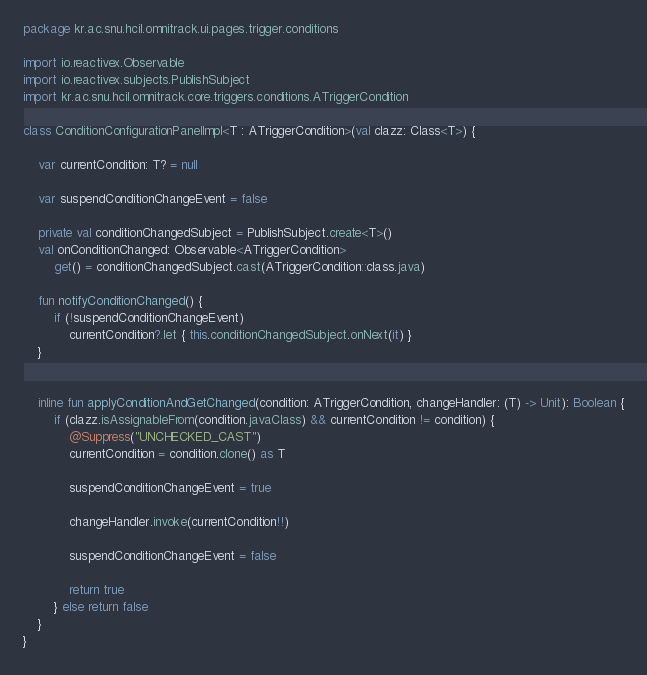<code> <loc_0><loc_0><loc_500><loc_500><_Kotlin_>package kr.ac.snu.hcil.omnitrack.ui.pages.trigger.conditions

import io.reactivex.Observable
import io.reactivex.subjects.PublishSubject
import kr.ac.snu.hcil.omnitrack.core.triggers.conditions.ATriggerCondition

class ConditionConfigurationPanelImpl<T : ATriggerCondition>(val clazz: Class<T>) {

    var currentCondition: T? = null

    var suspendConditionChangeEvent = false

    private val conditionChangedSubject = PublishSubject.create<T>()
    val onConditionChanged: Observable<ATriggerCondition>
        get() = conditionChangedSubject.cast(ATriggerCondition::class.java)

    fun notifyConditionChanged() {
        if (!suspendConditionChangeEvent)
            currentCondition?.let { this.conditionChangedSubject.onNext(it) }
    }


    inline fun applyConditionAndGetChanged(condition: ATriggerCondition, changeHandler: (T) -> Unit): Boolean {
        if (clazz.isAssignableFrom(condition.javaClass) && currentCondition != condition) {
            @Suppress("UNCHECKED_CAST")
            currentCondition = condition.clone() as T

            suspendConditionChangeEvent = true

            changeHandler.invoke(currentCondition!!)

            suspendConditionChangeEvent = false

            return true
        } else return false
    }
}</code> 